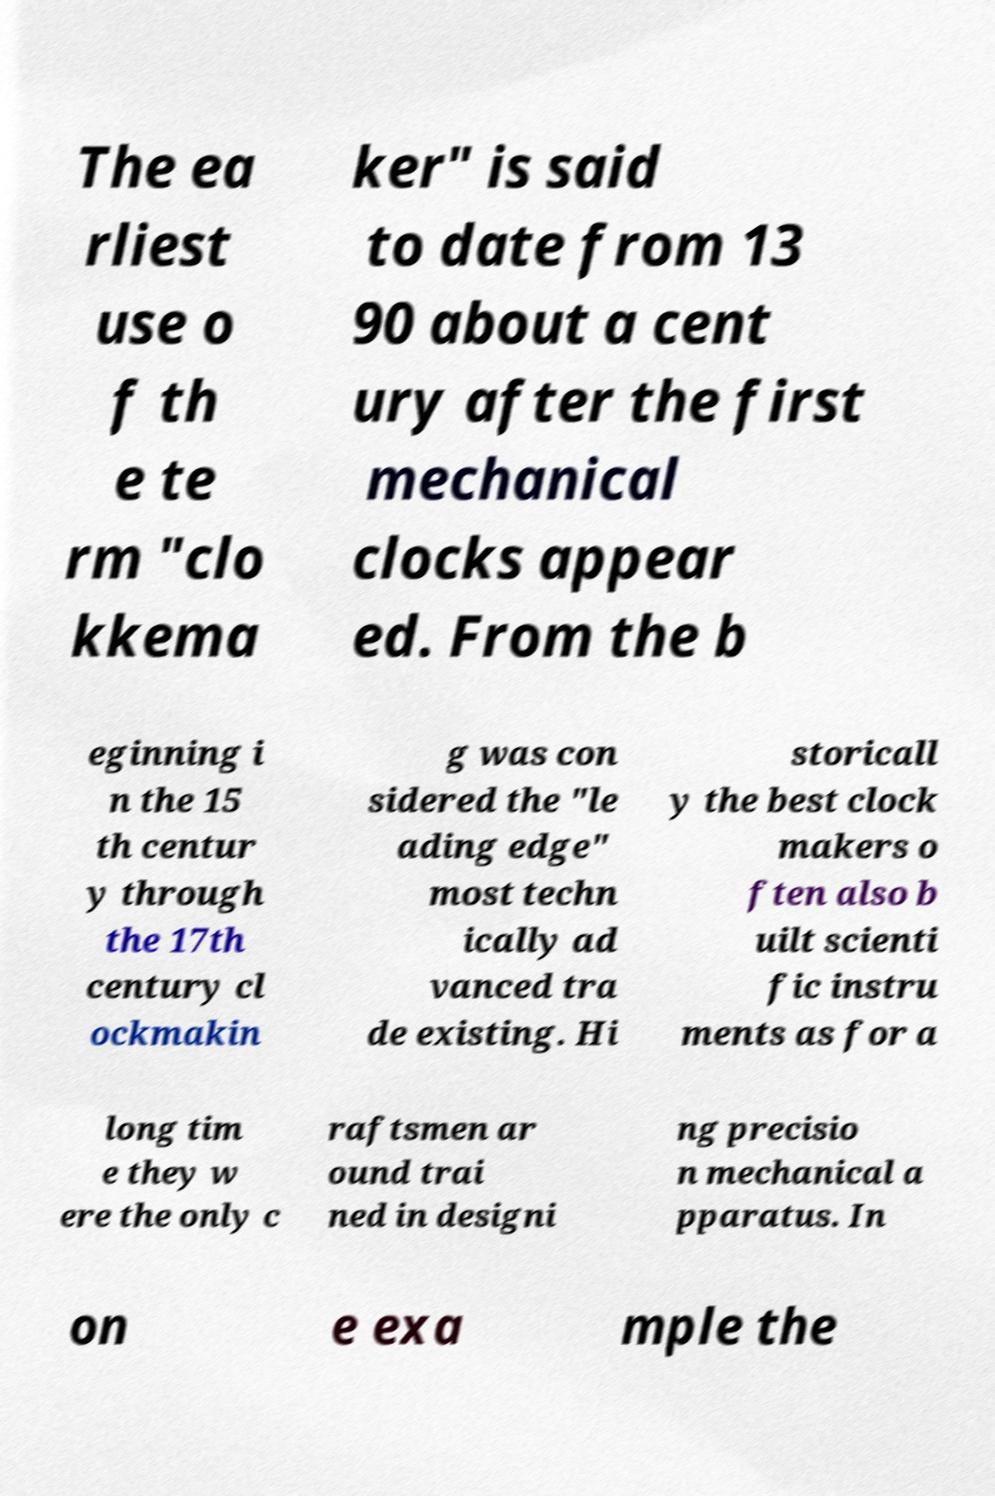For documentation purposes, I need the text within this image transcribed. Could you provide that? The ea rliest use o f th e te rm "clo kkema ker" is said to date from 13 90 about a cent ury after the first mechanical clocks appear ed. From the b eginning i n the 15 th centur y through the 17th century cl ockmakin g was con sidered the "le ading edge" most techn ically ad vanced tra de existing. Hi storicall y the best clock makers o ften also b uilt scienti fic instru ments as for a long tim e they w ere the only c raftsmen ar ound trai ned in designi ng precisio n mechanical a pparatus. In on e exa mple the 